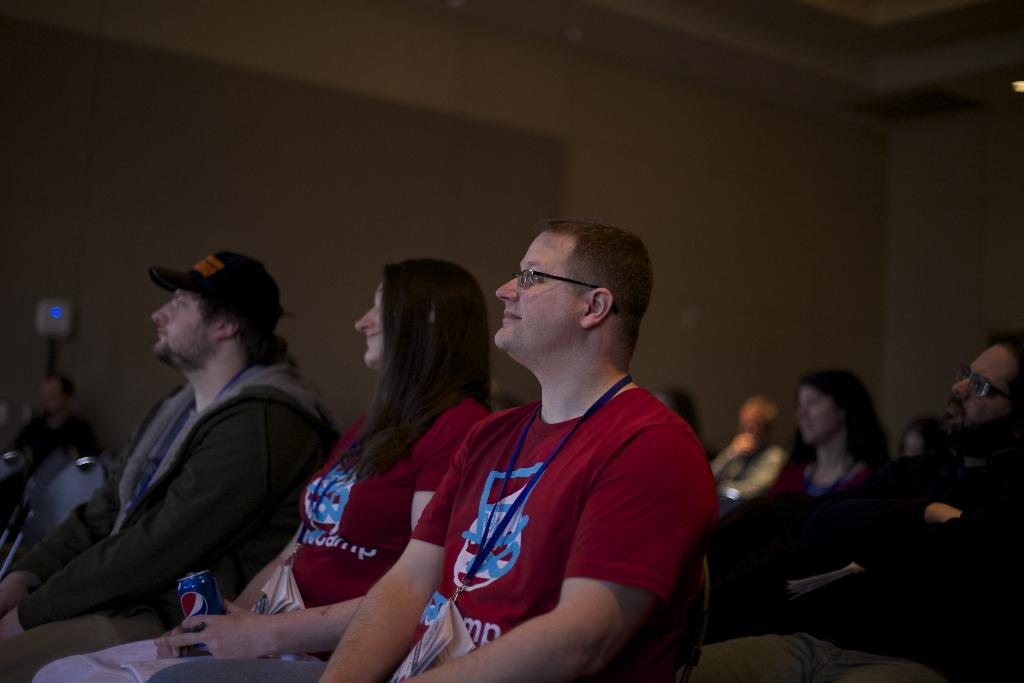How many people are in the image? There are a lot of people in the image. What are the people doing in the image? The people are sitting in chairs. Can you describe the background of the image? The background of the image is blurred. What type of vegetable is being sorted by the people in the image? There is no vegetable or sorting activity present in the image. 